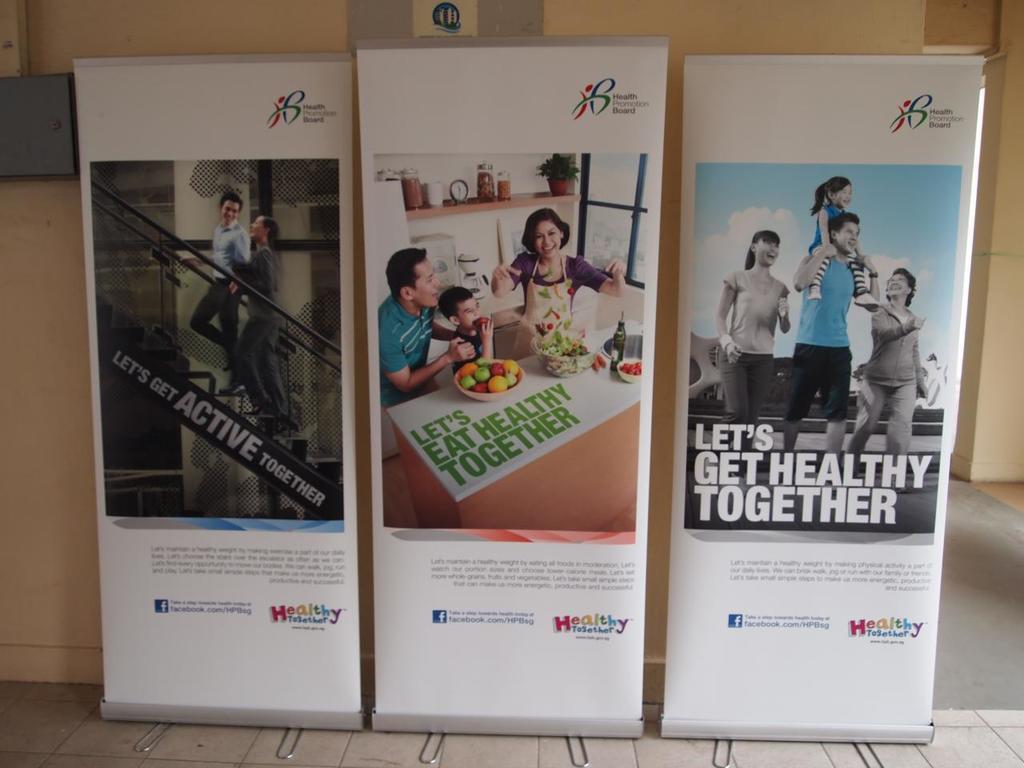Let's do what together?
Ensure brevity in your answer.  Get healthy. 